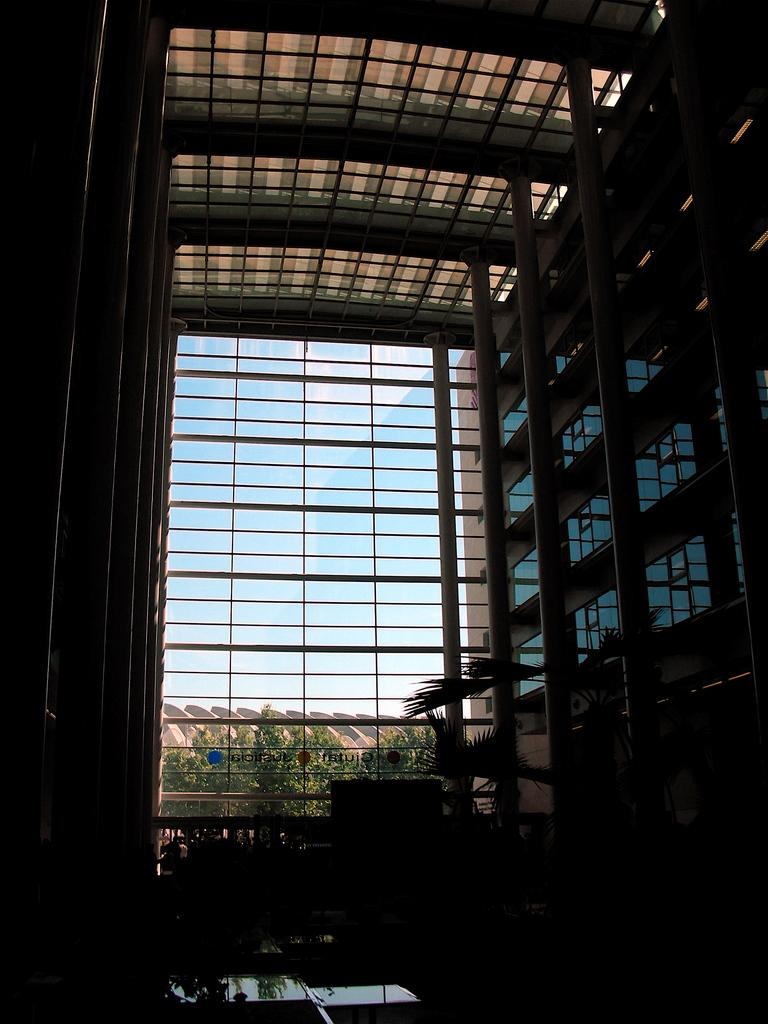What is the main subject of the image? The main subject of the image is a building. What type of natural elements can be seen in the image? There are trees in the image. Are there any other structures visible in the image? Yes, there are other buildings in the image. What is visible at the top of the image? The sky is visible at the top of the image. How many giants can be seen walking around the building in the image? There are no giants present in the image. What force is causing the building to sway in the image? There is no indication of any force causing the building to sway in the image. 